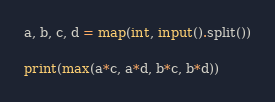Convert code to text. <code><loc_0><loc_0><loc_500><loc_500><_Python_>a, b, c, d = map(int, input().split())

print(max(a*c, a*d, b*c, b*d))</code> 